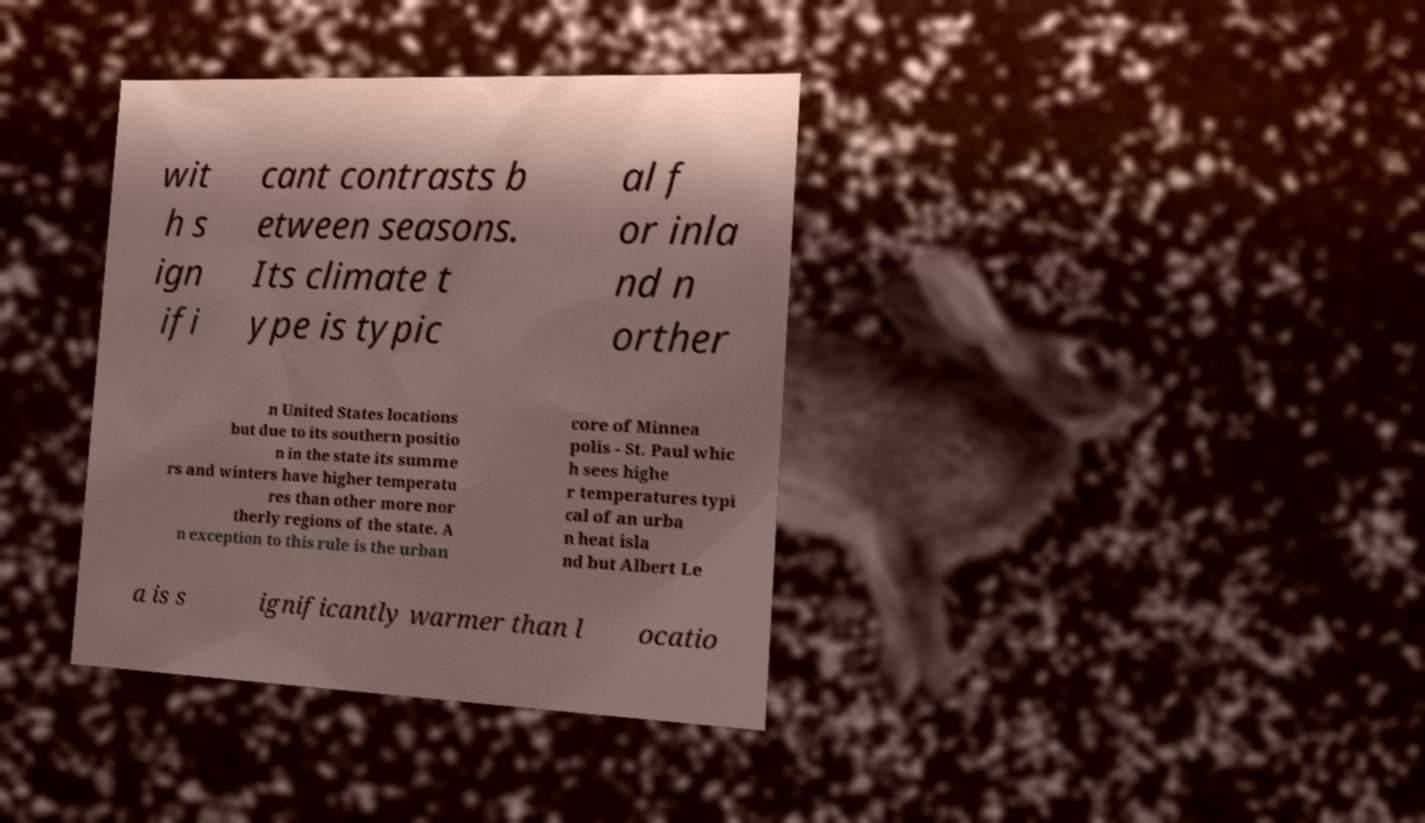What messages or text are displayed in this image? I need them in a readable, typed format. wit h s ign ifi cant contrasts b etween seasons. Its climate t ype is typic al f or inla nd n orther n United States locations but due to its southern positio n in the state its summe rs and winters have higher temperatu res than other more nor therly regions of the state. A n exception to this rule is the urban core of Minnea polis - St. Paul whic h sees highe r temperatures typi cal of an urba n heat isla nd but Albert Le a is s ignificantly warmer than l ocatio 